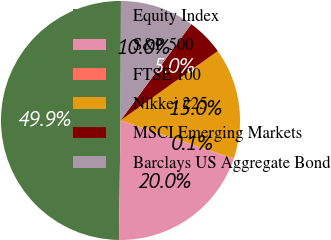<chart> <loc_0><loc_0><loc_500><loc_500><pie_chart><fcel>Equity Index<fcel>S&P 500<fcel>FTSE 100<fcel>Nikkei 225<fcel>MSCI Emerging Markets<fcel>Barclays US Aggregate Bond<nl><fcel>49.87%<fcel>19.99%<fcel>0.07%<fcel>15.01%<fcel>5.05%<fcel>10.03%<nl></chart> 